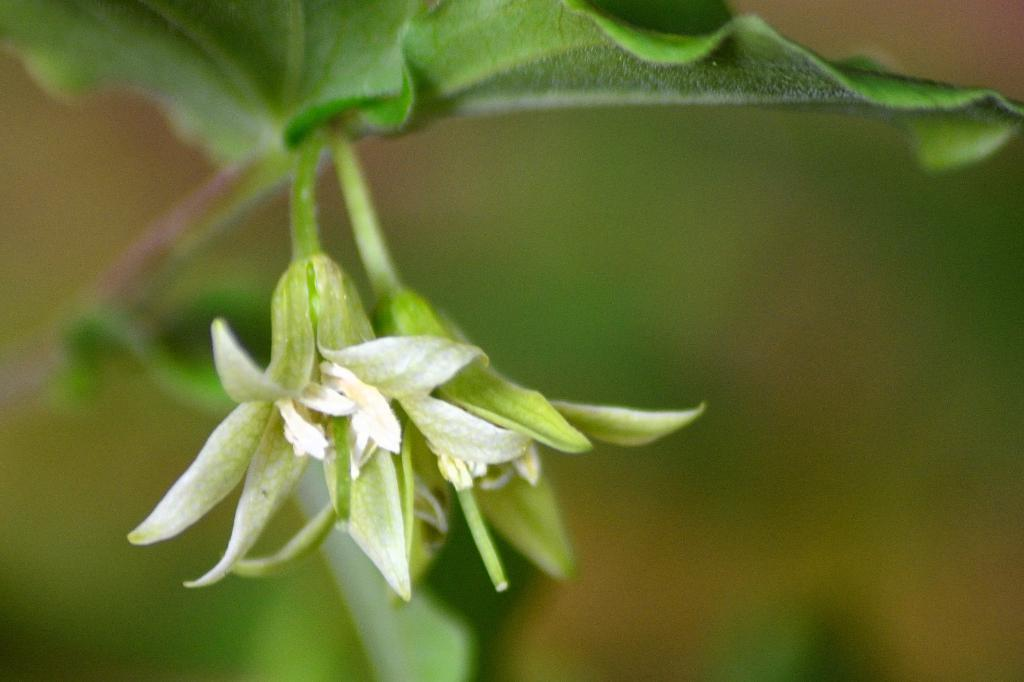What is the main subject of the picture? The main subject of the picture is a flower plant. Can you describe the background of the image? The background of the image is blurred. What type of cord is used to hang the show in the image? There is no show or cord present in the image; it features a flower plant with a blurred background. 